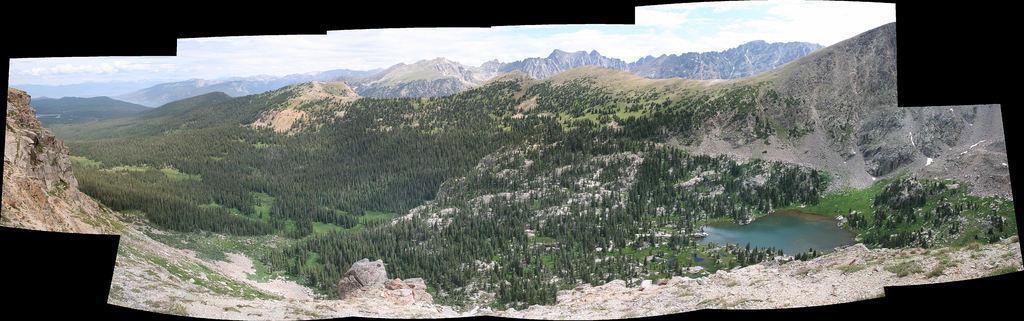What type of vegetation can be seen in the image? There are trees in the image. What natural element is visible in the image? There is water visible in the image. What type of landscape feature is present in the image? There are hills in the image. What material is present in the image? Stones are present in the image. What is visible in the sky in the image? The sky is visible in the image, and clouds are present. What type of celery is being used as a prop in the image? There is no celery present in the image. What is the title of the image? The image does not have a title. 